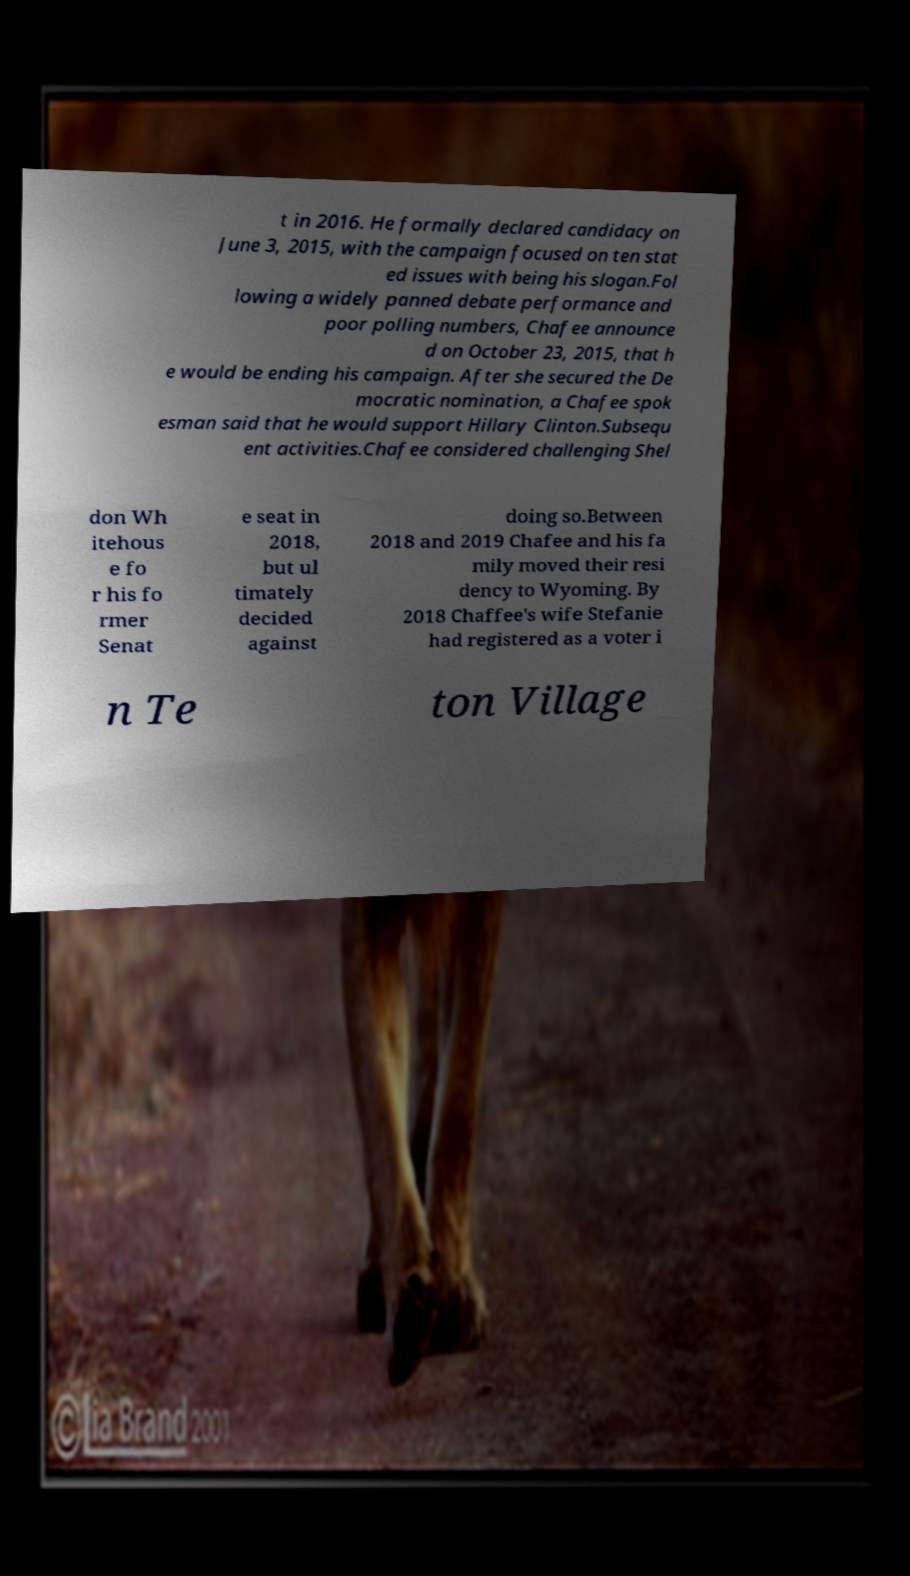There's text embedded in this image that I need extracted. Can you transcribe it verbatim? t in 2016. He formally declared candidacy on June 3, 2015, with the campaign focused on ten stat ed issues with being his slogan.Fol lowing a widely panned debate performance and poor polling numbers, Chafee announce d on October 23, 2015, that h e would be ending his campaign. After she secured the De mocratic nomination, a Chafee spok esman said that he would support Hillary Clinton.Subsequ ent activities.Chafee considered challenging Shel don Wh itehous e fo r his fo rmer Senat e seat in 2018, but ul timately decided against doing so.Between 2018 and 2019 Chafee and his fa mily moved their resi dency to Wyoming. By 2018 Chaffee's wife Stefanie had registered as a voter i n Te ton Village 